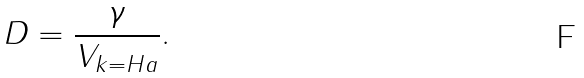<formula> <loc_0><loc_0><loc_500><loc_500>D = \frac { \gamma } { V _ { k = H a } } .</formula> 